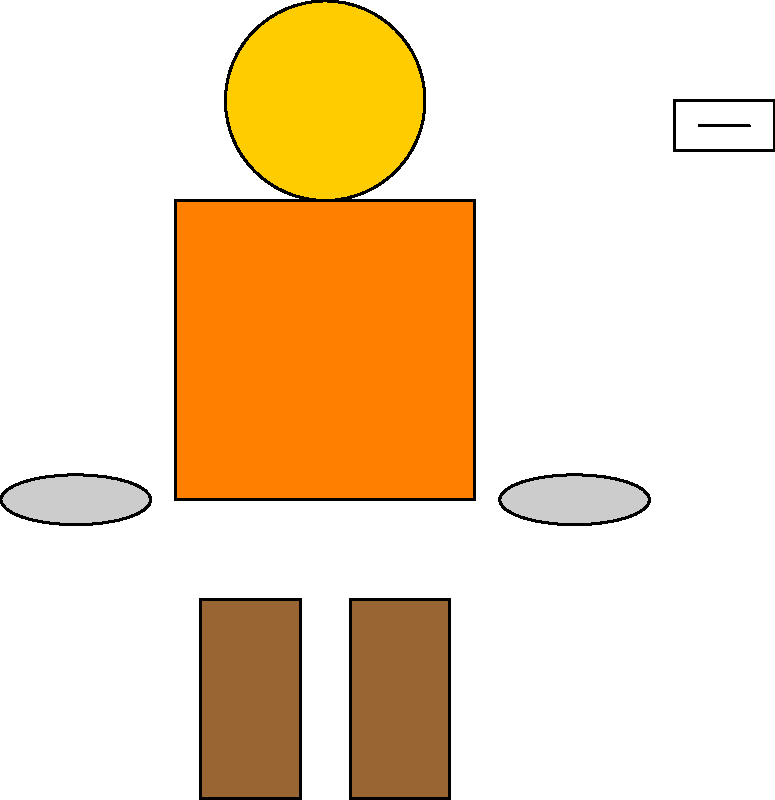Which of the following PPE items is NOT represented in the image above?
A) Hard hat
B) Safety glasses
C) Safety vest
D) Respirator mask
E) Work boots Let's analyze the PPE items shown in the image:

1. Hard hat: A yellow circular object is visible at the top of the image, representing a hard hat.
2. Safety glasses: A small rectangular object with a line in the middle is shown in the upper right corner, representing safety glasses.
3. Safety vest: A large rectangular object in the center of the image represents a high-visibility safety vest.
4. Work boots: Two rectangular objects at the bottom of the image represent work boots.
5. Gloves: Two oval shapes on either side of the vest represent work gloves.

Comparing this to the options given:
A) Hard hat - Present
B) Safety glasses - Present
C) Safety vest - Present
D) Respirator mask - Not present in the image
E) Work boots - Present

The only item from the list that is not represented in the image is the respirator mask.
Answer: D) Respirator mask 